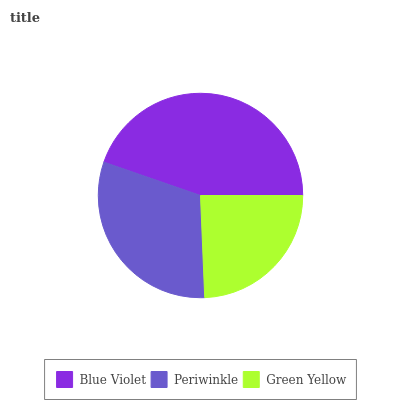Is Green Yellow the minimum?
Answer yes or no. Yes. Is Blue Violet the maximum?
Answer yes or no. Yes. Is Periwinkle the minimum?
Answer yes or no. No. Is Periwinkle the maximum?
Answer yes or no. No. Is Blue Violet greater than Periwinkle?
Answer yes or no. Yes. Is Periwinkle less than Blue Violet?
Answer yes or no. Yes. Is Periwinkle greater than Blue Violet?
Answer yes or no. No. Is Blue Violet less than Periwinkle?
Answer yes or no. No. Is Periwinkle the high median?
Answer yes or no. Yes. Is Periwinkle the low median?
Answer yes or no. Yes. Is Green Yellow the high median?
Answer yes or no. No. Is Blue Violet the low median?
Answer yes or no. No. 